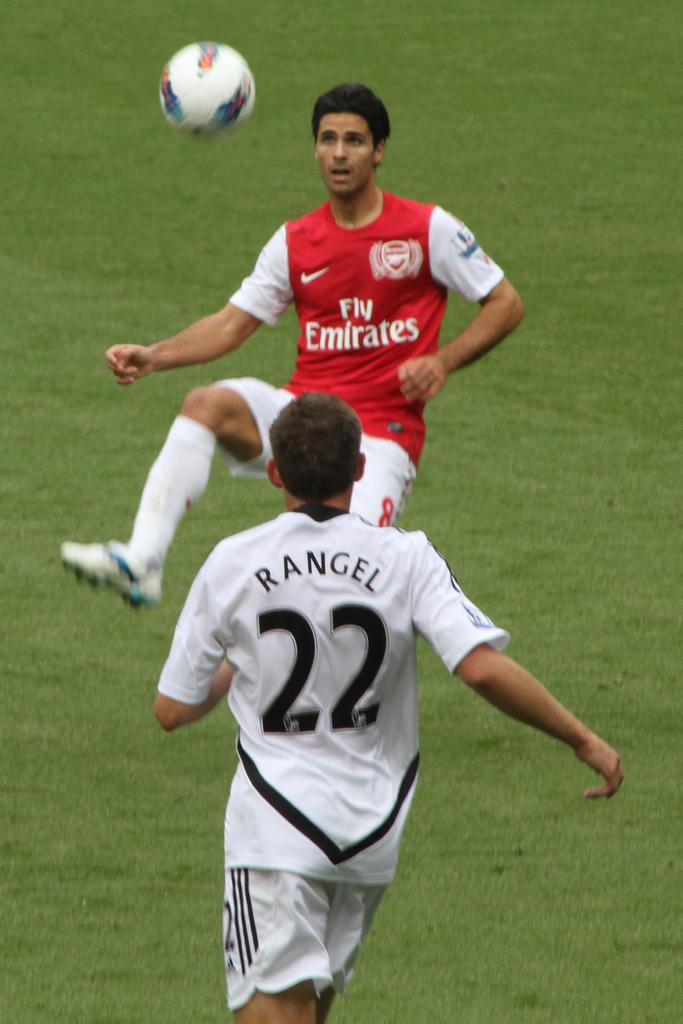What number is on the white jersey?
Offer a very short reply. 22. What teams are playing soccer?
Give a very brief answer. Fly emirates. 